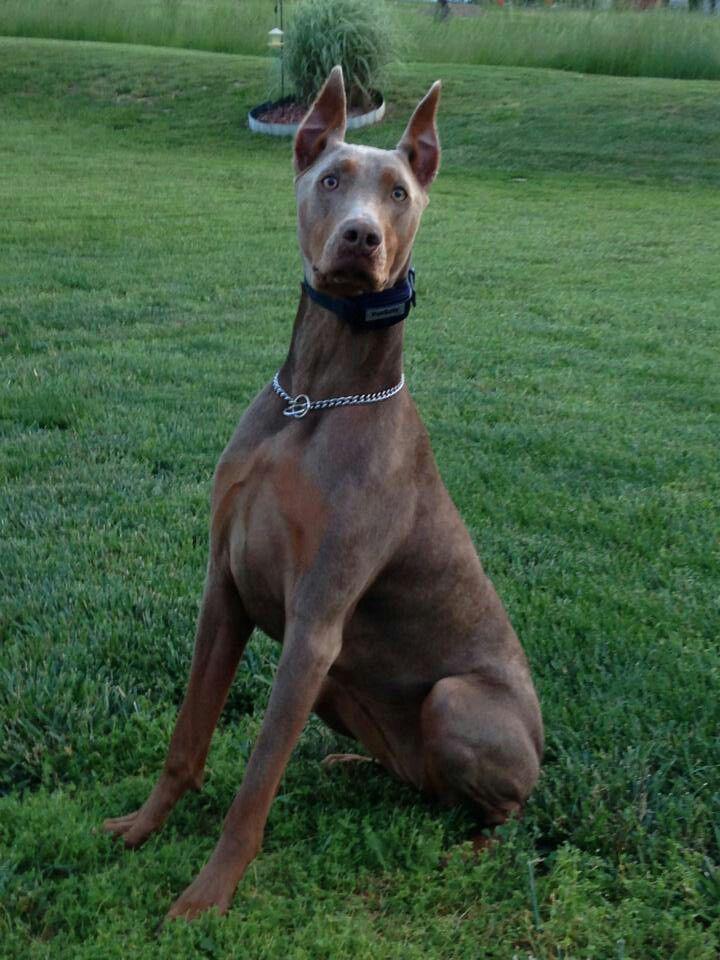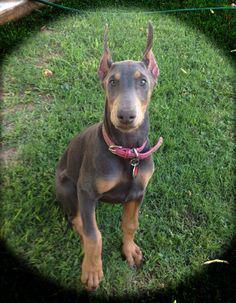The first image is the image on the left, the second image is the image on the right. Given the left and right images, does the statement "There is only one dog in each picture and both have similar positions." hold true? Answer yes or no. Yes. The first image is the image on the left, the second image is the image on the right. For the images shown, is this caption "There is only one dog in each image and it has a collar on." true? Answer yes or no. Yes. 